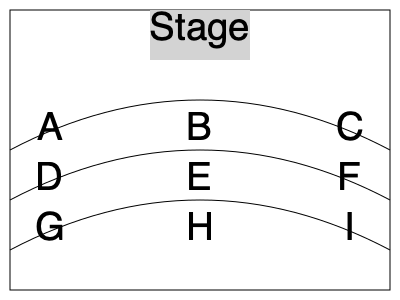Based on the seating chart layout shown, which section would provide the best acoustics for a vocal performance, considering the typical structure of a concert hall? To determine the best acoustics for a vocal performance, we need to consider the following factors:

1. Distance from the stage: Closer seats generally provide better sound quality, as the sound doesn't have to travel as far.

2. Central positioning: Seats in the center of the hall often offer more balanced acoustics, as they receive sound evenly from both sides of the stage.

3. Elevation: In a typical concert hall, seats slightly elevated and further back can sometimes provide excellent acoustics due to the natural amplification of the hall's design.

4. Shape of the hall: The curved layout suggests this is a shoebox or horseshoe-shaped hall, which are known for good acoustics.

Considering these factors:

- Sections A, B, and C are closest to the stage, with B being centrally located.
- Sections D, E, and F are slightly further back but still relatively close, with E being central.
- Sections G, H, and I are the furthest back but may benefit from elevation.

Among these, section B stands out as the optimal choice:
- It's centrally located, ensuring balanced sound from both sides of the stage.
- It's in the front row, closest to the stage, which is crucial for vocal performances where subtle nuances are important.
- In a shoebox or horseshoe-shaped hall, this central position often falls in the "sweet spot" for acoustics.

Therefore, section B would likely provide the best acoustics for a vocal performance in this concert hall layout.
Answer: Section B 